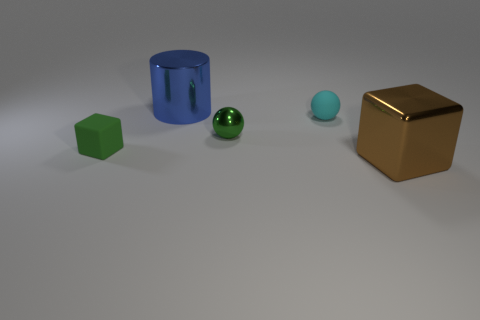What is the material of the tiny green object that is the same shape as the tiny cyan rubber thing?
Make the answer very short. Metal. Are there more tiny green rubber cubes to the right of the blue metal cylinder than small green metal spheres that are to the right of the cyan matte sphere?
Your answer should be compact. No. The tiny object that is the same material as the large cylinder is what shape?
Provide a short and direct response. Sphere. Is the number of tiny rubber objects on the left side of the cylinder greater than the number of gray cylinders?
Provide a short and direct response. Yes. How many tiny things have the same color as the metallic ball?
Make the answer very short. 1. What number of other things are there of the same color as the small block?
Your answer should be very brief. 1. Is the number of green rubber objects greater than the number of large green shiny cylinders?
Ensure brevity in your answer.  Yes. What is the material of the green cube?
Give a very brief answer. Rubber. There is a metal object behind the green ball; is it the same size as the green rubber thing?
Your response must be concise. No. There is a cyan rubber sphere behind the large brown block; what is its size?
Offer a very short reply. Small. 